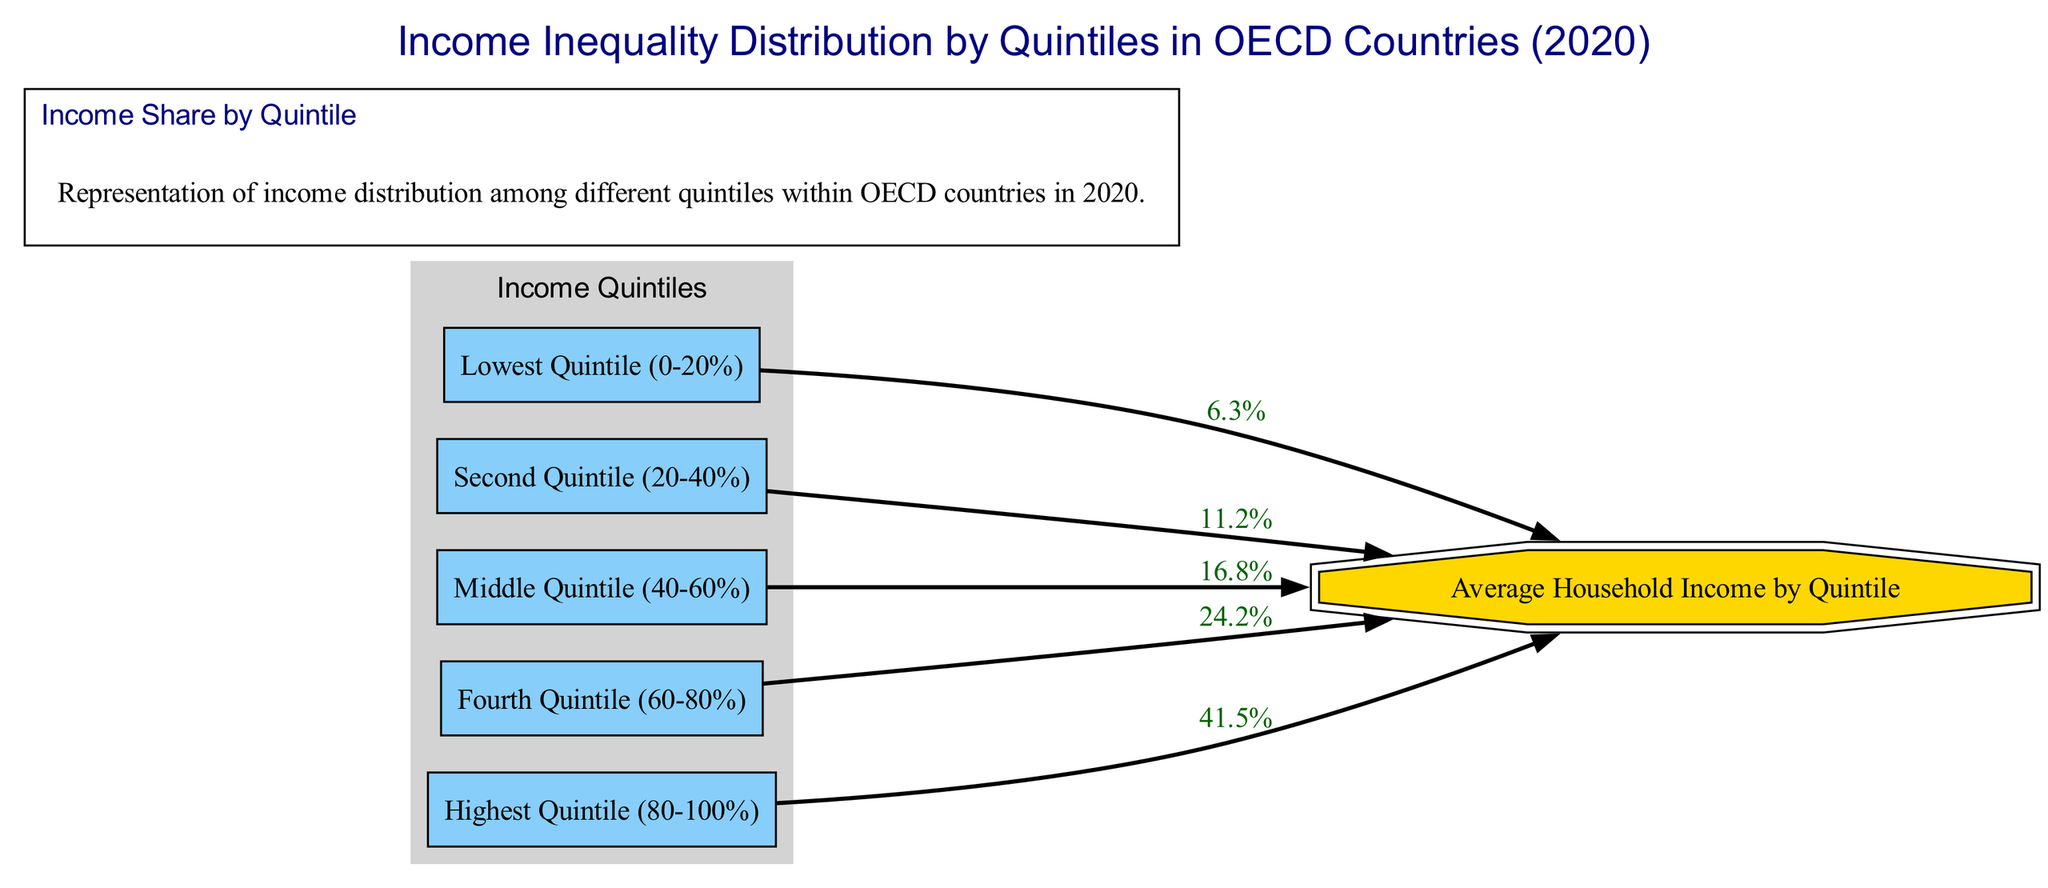What is the income share of the lowest quintile? The diagram shows that the lowest quintile (Q1) has an income share labeled as 6.3% leading to the Average Household Income node. This represents the percentage of total income that this quintile receives.
Answer: 6.3% How many quintiles are represented in the diagram? The diagram includes five nodes for quintiles, which are labeled Q1 through Q5. Each of these represents a distinct income segment. Hence, the total is five.
Answer: 5 What is the income share of the highest quintile? The highest quintile (Q5) is connected to the Average Household Income node with an income share of 41.5%. This indicates the proportion of total income held by this quintile.
Answer: 41.5% Which quintile has the largest income share? By observing the connections to the Average Income node, the highest quintile (Q5) is shown with the largest share of 41.5%, more than all other quintiles.
Answer: Highest Quintile (80-100%) What is the combined income share of the second and third quintiles? The second quintile (Q2) shares 11.2% and the third quintile (Q3) shares 16.8%. Adding these two values together (11.2% + 16.8%) gives 28% as their combined income share.
Answer: 28% Which quintile corresponds to an income share of 24.2%? The diagram directly connects the fourth quintile (Q4) to the Average Income node, showing that it has an income share of 24.2%.
Answer: Fourth Quintile (60-80%) What is the average income share of the middle quintile? The middle quintile (Q3) is indicated to have an income share of 16.8% which corresponds to its relationship to the Average Household Income node.
Answer: 16.8% How does the income share of Q4 compare to Q2? Q4 has an income share of 24.2%, while Q2 has an income share of 11.2%. Comparing these values shows that Q4's share is significantly larger than Q2's share.
Answer: Larger than Q2 